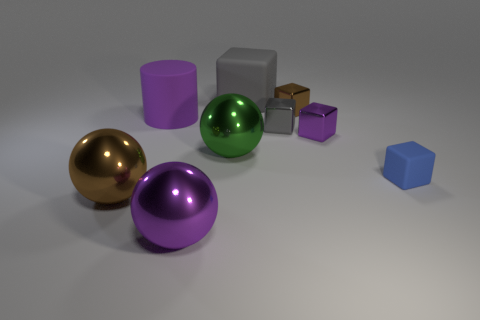Subtract 1 cubes. How many cubes are left? 4 Subtract all brown cubes. How many cubes are left? 4 Subtract all purple cubes. How many cubes are left? 4 Subtract all red blocks. Subtract all gray cylinders. How many blocks are left? 5 Add 1 green things. How many objects exist? 10 Subtract all cylinders. How many objects are left? 8 Subtract all brown balls. Subtract all tiny brown metal cylinders. How many objects are left? 8 Add 7 large green metal balls. How many large green metal balls are left? 8 Add 8 small shiny cylinders. How many small shiny cylinders exist? 8 Subtract 0 green cylinders. How many objects are left? 9 